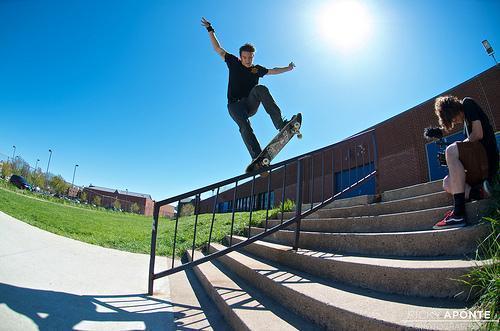How many people are there?
Give a very brief answer. 2. 